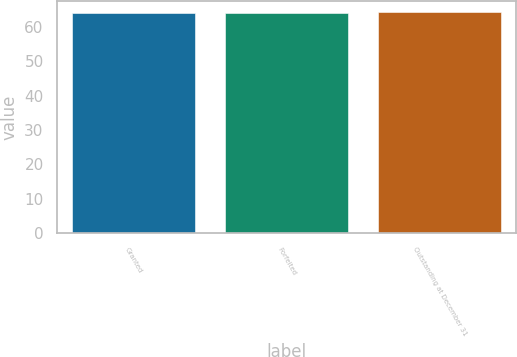<chart> <loc_0><loc_0><loc_500><loc_500><bar_chart><fcel>Granted<fcel>Forfeited<fcel>Outstanding at December 31<nl><fcel>64.14<fcel>64.24<fcel>64.34<nl></chart> 